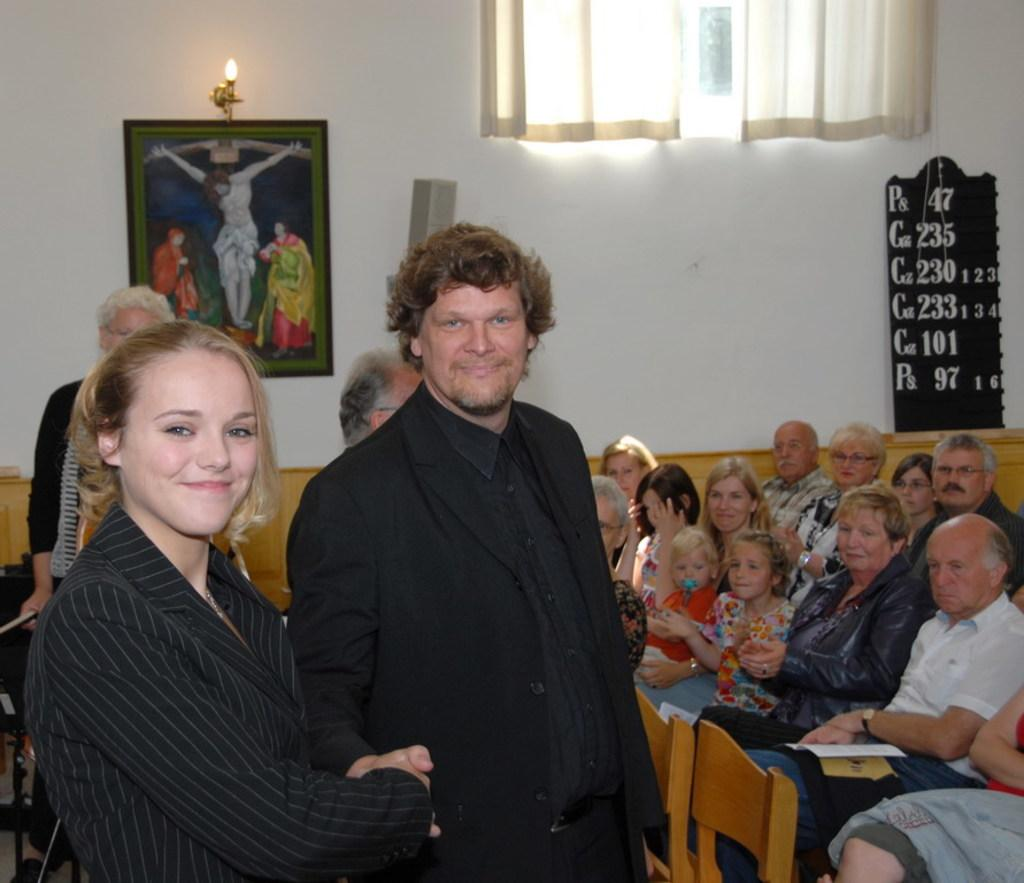Who or what can be seen in the image? There are people in the image. What objects are present for seating? There are chairs in the image. What type of structure is visible in the image? There is a frame in the image. What type of architectural feature is present? There is a wall in the image. What is the purpose of the board in the image? There is a board in the image, but its purpose cannot be determined from the facts provided. What type of window treatment is present in the image? There is a curtain in the image. What type of metal is the chess set made of in the image? There is no chess set present in the image, so it cannot be determined what type of metal it might be made of. 